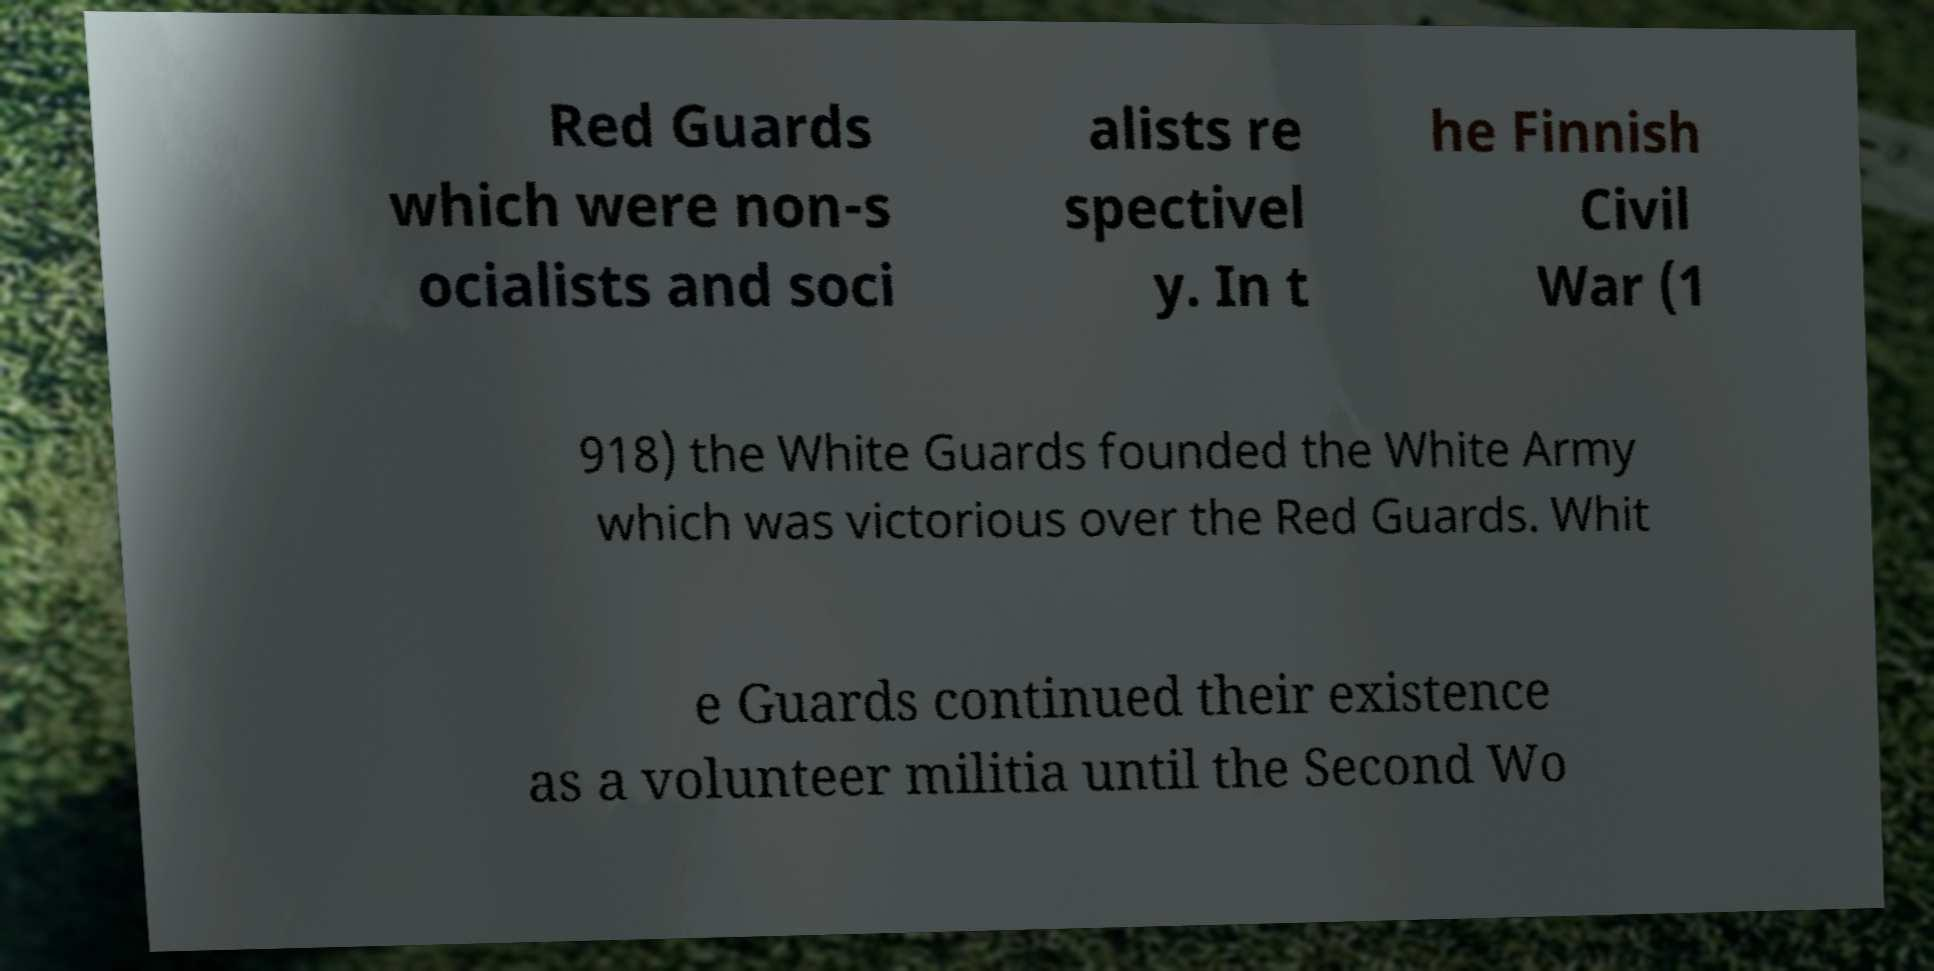There's text embedded in this image that I need extracted. Can you transcribe it verbatim? Red Guards which were non-s ocialists and soci alists re spectivel y. In t he Finnish Civil War (1 918) the White Guards founded the White Army which was victorious over the Red Guards. Whit e Guards continued their existence as a volunteer militia until the Second Wo 